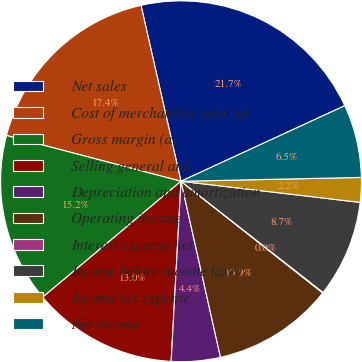<chart> <loc_0><loc_0><loc_500><loc_500><pie_chart><fcel>Net sales<fcel>Cost of merchandise sold (a)<fcel>Gross margin (a)<fcel>Selling general and<fcel>Depreciation and amortization<fcel>Operating income<fcel>Interest expense net<fcel>Income before income taxes<fcel>Income tax expense<fcel>Net income<nl><fcel>21.68%<fcel>17.36%<fcel>15.19%<fcel>13.03%<fcel>4.38%<fcel>10.87%<fcel>0.05%<fcel>8.7%<fcel>2.21%<fcel>6.54%<nl></chart> 